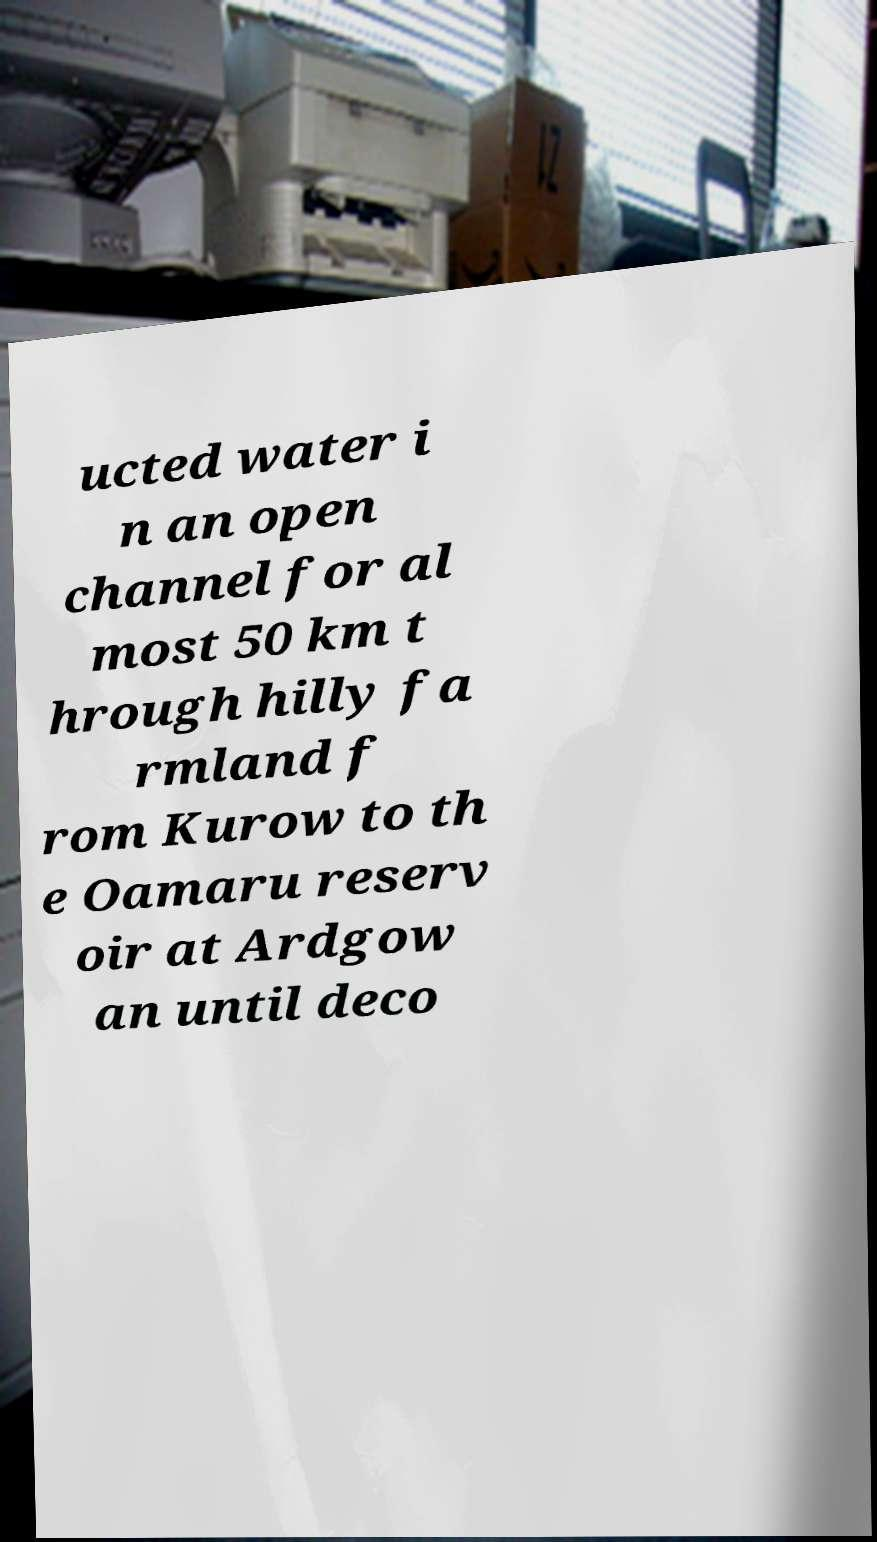For documentation purposes, I need the text within this image transcribed. Could you provide that? ucted water i n an open channel for al most 50 km t hrough hilly fa rmland f rom Kurow to th e Oamaru reserv oir at Ardgow an until deco 